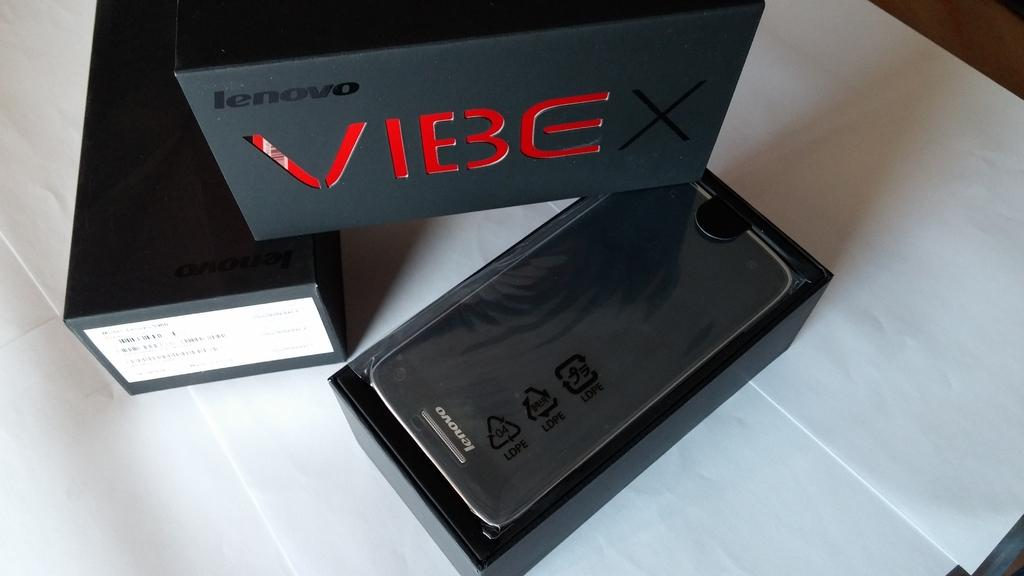<image>
Present a compact description of the photo's key features. A lenovo Vibe smartphone in the original box 